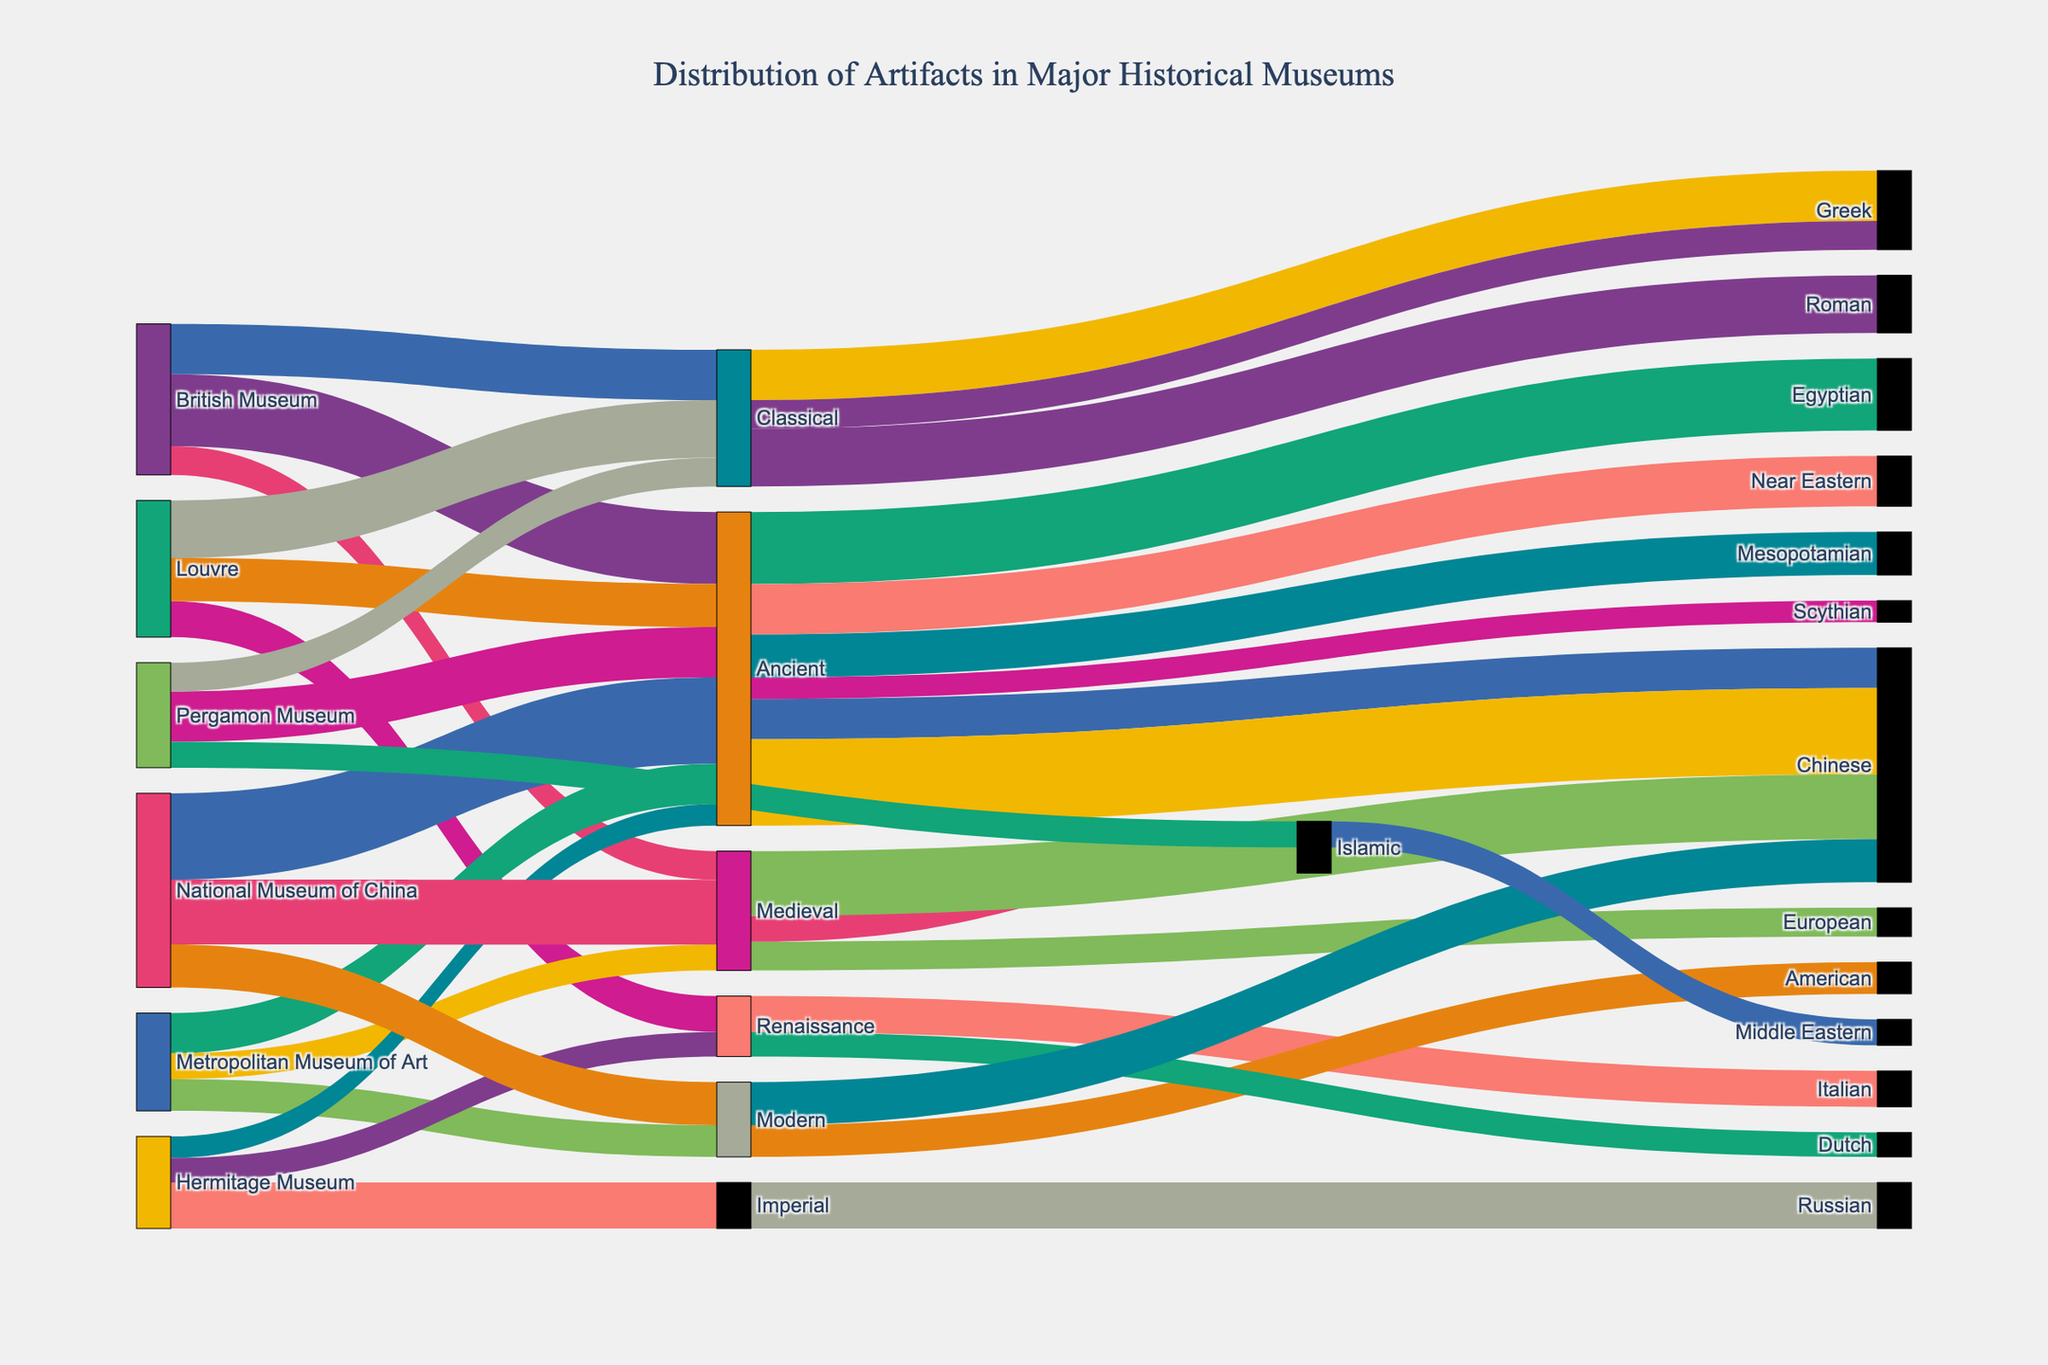What's the total count of Ancient Egyptian artifacts? First, identify the relevant node labeled "Ancient Egyptian." Then, trace back to the source node labeled "British Museum." The flow value connecting these nodes indicates the count: 5,000.
Answer: 5,000 Which museum has the most artifacts from the Renaissance era? Observe the nodes labeled by the museums and Renaissance. The flow values from the Renaissance node to the museums show the Louvre has the largest flow value of 2,500.
Answer: Louvre How many Chinese artifacts are there in the National Museum of China? Locate the "National Museum of China" node and follow the flow values connected to nodes labeled "Chinese." Sum the flow values to give the total: 6,000 (Ancient) + 4,500 (Medieval) + 3,000 (Modern) = 13,500.
Answer: 13,500 What is the difference in the number of Greek artifacts between the British Museum and the Pergamon Museum? Identify the flow value from the British Museum to Greek (3,500) and the Pergamon Museum to Greek (2,000). Subtract the smaller number from the larger: 3,500 - 2,000 = 1,500.
Answer: 1,500 Which era has the smallest number of artifacts in the Hermitage Museum? Examine the flow values connected between the Hermitage Museum node and different era nodes. The smallest flow value is from the Ancient era, with 1,500.
Answer: Ancient How many artifacts are there in total from the Classical era among all museums? Identify all flows from different museums to the Classical era nodes, and sum these values: British Museum (3,500) + Louvre (4,000) + Pergamon Museum (2,000) = 9,500.
Answer: 9,500 Compare the number of Medieval artifacts in the Metropolitan Museum of Art with the Hermitage Museum. Which is greater and by how much? Determine the flow values from the Medieval node to the Metropolitan Museum of Art (1,800) and the Hermitage Museum (0, since Hermitage Museum has no link to Medieval). The difference is 1,800.
Answer: Metropolitan Museum of Art is greater by 1,800 What is the total count of artifacts in the Louvre Museum? Sum the flow values from the Louvre Museum to different era nodes and civilizations: 3,000 (Ancient Mesopotamian) + 2,500 (Renaissance Italian) + 4,000 (Classical Roman) = 9,500.
Answer: 9,500 Which civilization has the largest number of artifacts, and what is that number? Identify the civilization node that has the highest linked flow value. The largest value is from the Chinese civilization with a total of 13,500 artifacts in the National Museum of China.
Answer: Chinese, 13,500 